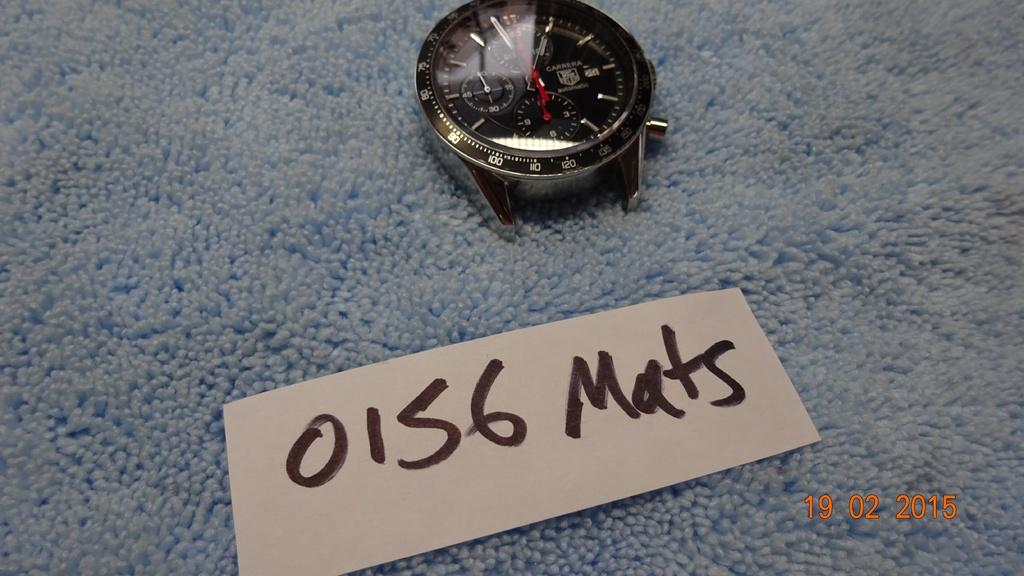<image>
Write a terse but informative summary of the picture. A watch is set on a blue plush surface with the marker 0156 Mats by it. 